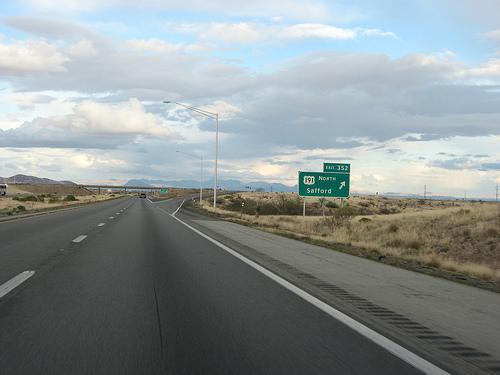How many signs are in this picture?
Give a very brief answer. 1. 